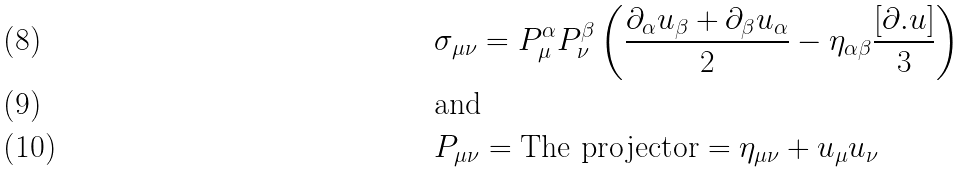Convert formula to latex. <formula><loc_0><loc_0><loc_500><loc_500>& \sigma _ { \mu \nu } = P ^ { \alpha } _ { \mu } P ^ { \beta } _ { \nu } \left ( \frac { \partial _ { \alpha } u _ { \beta } + \partial _ { \beta } u _ { \alpha } } { 2 } - \eta _ { \alpha \beta } \frac { [ \partial . u ] } { 3 } \right ) \\ & \text {and} \\ & P _ { \mu \nu } = \text {The projector} = \eta _ { \mu \nu } + u _ { \mu } u _ { \nu }</formula> 